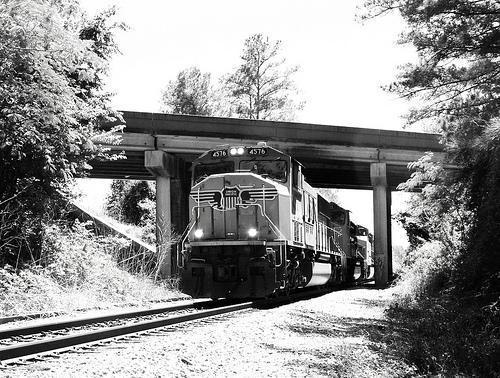How many trains on the train tracks?
Give a very brief answer. 1. 